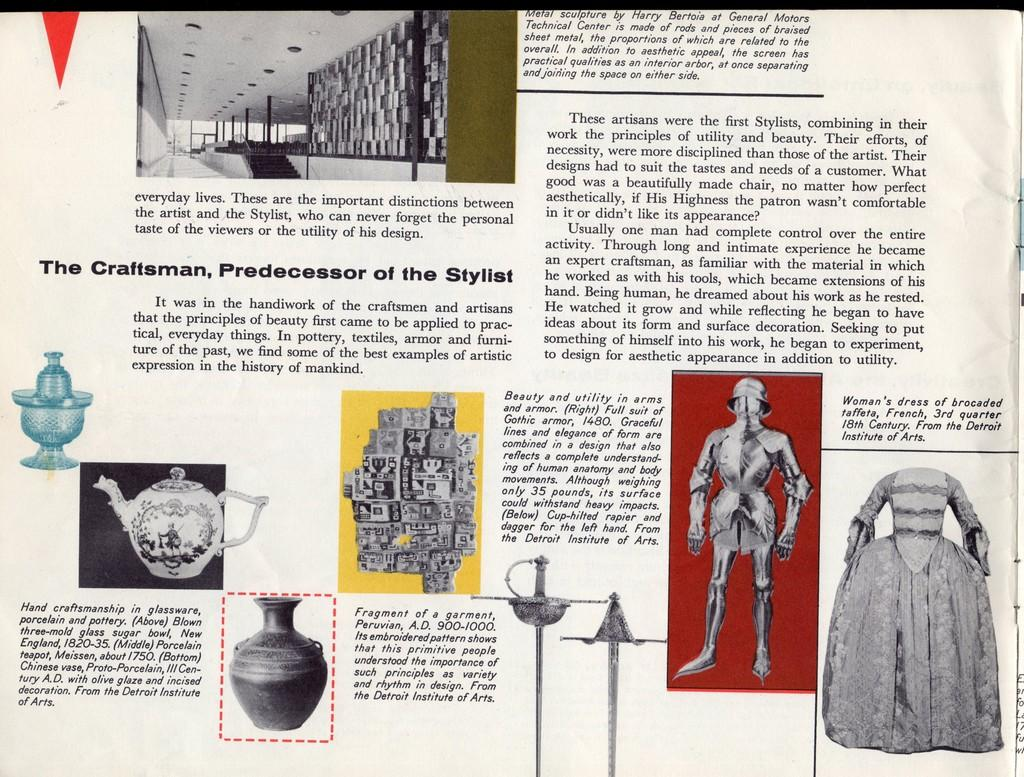What is present in the image that contains visual and written information? There is a paper in the image that contains pictures and text. Can you describe the content of the paper? The paper contains pictures and text. What type of toy is depicted in the picture on the paper? There is no toy depicted in the picture on the paper; the paper contains pictures and text, but no specific toy is mentioned. 